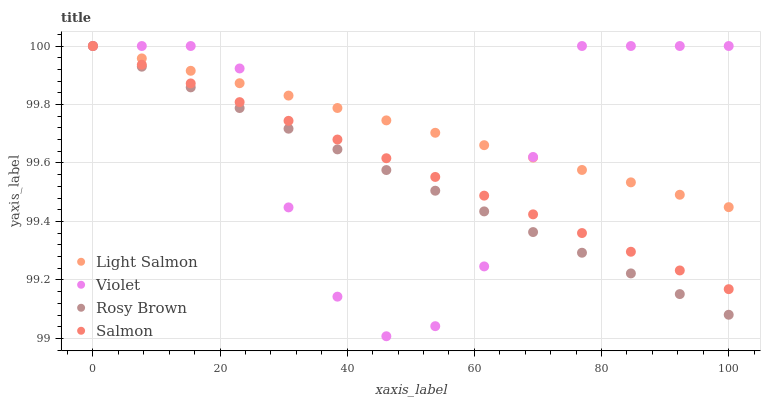Does Rosy Brown have the minimum area under the curve?
Answer yes or no. Yes. Does Light Salmon have the maximum area under the curve?
Answer yes or no. Yes. Does Salmon have the minimum area under the curve?
Answer yes or no. No. Does Salmon have the maximum area under the curve?
Answer yes or no. No. Is Light Salmon the smoothest?
Answer yes or no. Yes. Is Violet the roughest?
Answer yes or no. Yes. Is Rosy Brown the smoothest?
Answer yes or no. No. Is Rosy Brown the roughest?
Answer yes or no. No. Does Violet have the lowest value?
Answer yes or no. Yes. Does Rosy Brown have the lowest value?
Answer yes or no. No. Does Violet have the highest value?
Answer yes or no. Yes. Does Violet intersect Salmon?
Answer yes or no. Yes. Is Violet less than Salmon?
Answer yes or no. No. Is Violet greater than Salmon?
Answer yes or no. No. 